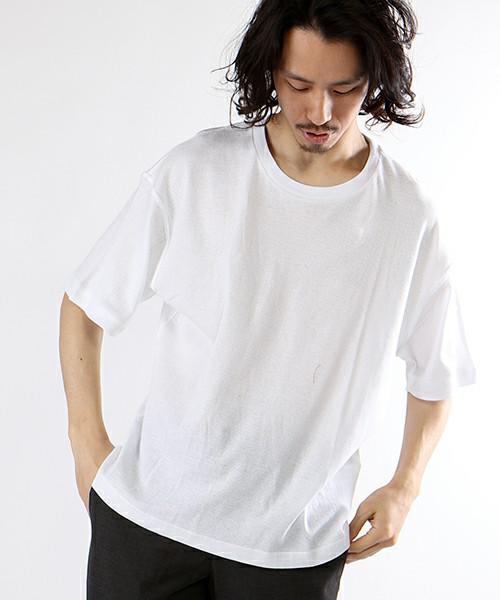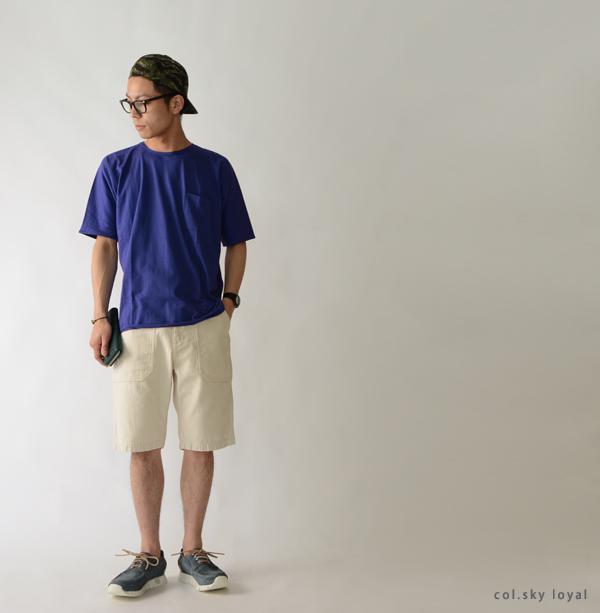The first image is the image on the left, the second image is the image on the right. Assess this claim about the two images: "the white t-shirt in the image on the left has a breast pocket". Correct or not? Answer yes or no. No. The first image is the image on the left, the second image is the image on the right. Considering the images on both sides, is "All shirts are white or blue, and have short sleeves." valid? Answer yes or no. Yes. 